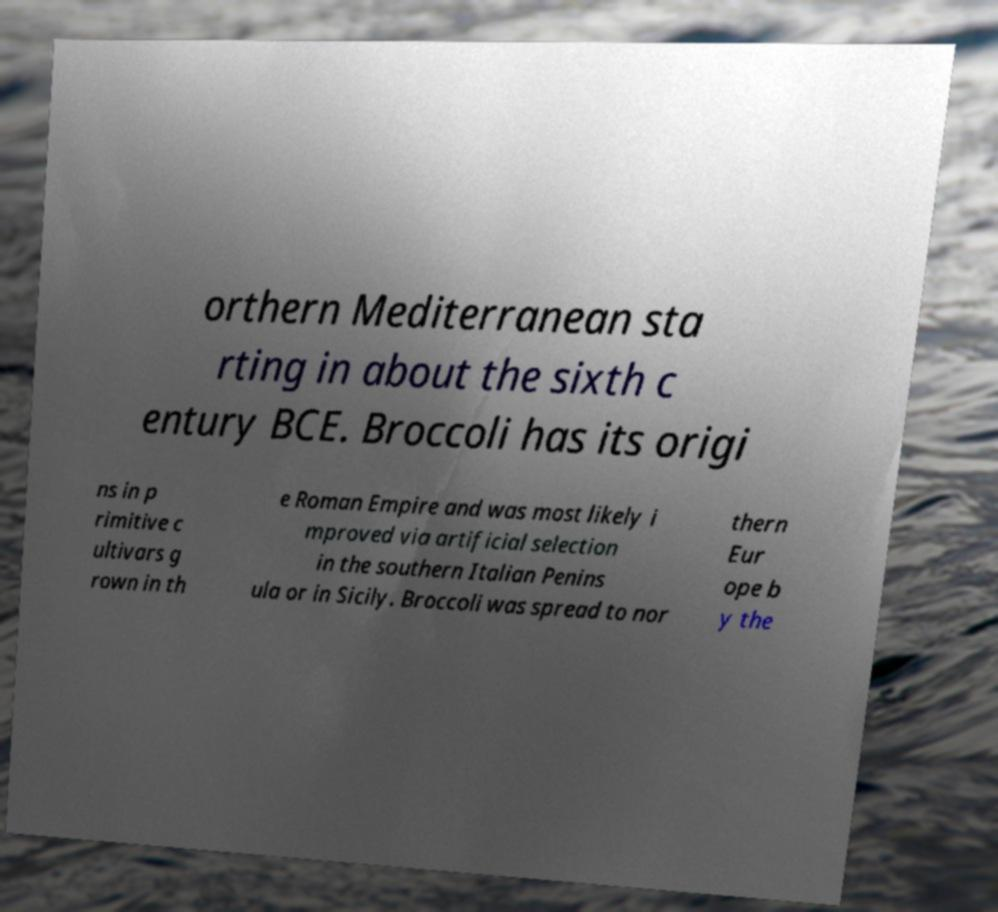What messages or text are displayed in this image? I need them in a readable, typed format. orthern Mediterranean sta rting in about the sixth c entury BCE. Broccoli has its origi ns in p rimitive c ultivars g rown in th e Roman Empire and was most likely i mproved via artificial selection in the southern Italian Penins ula or in Sicily. Broccoli was spread to nor thern Eur ope b y the 